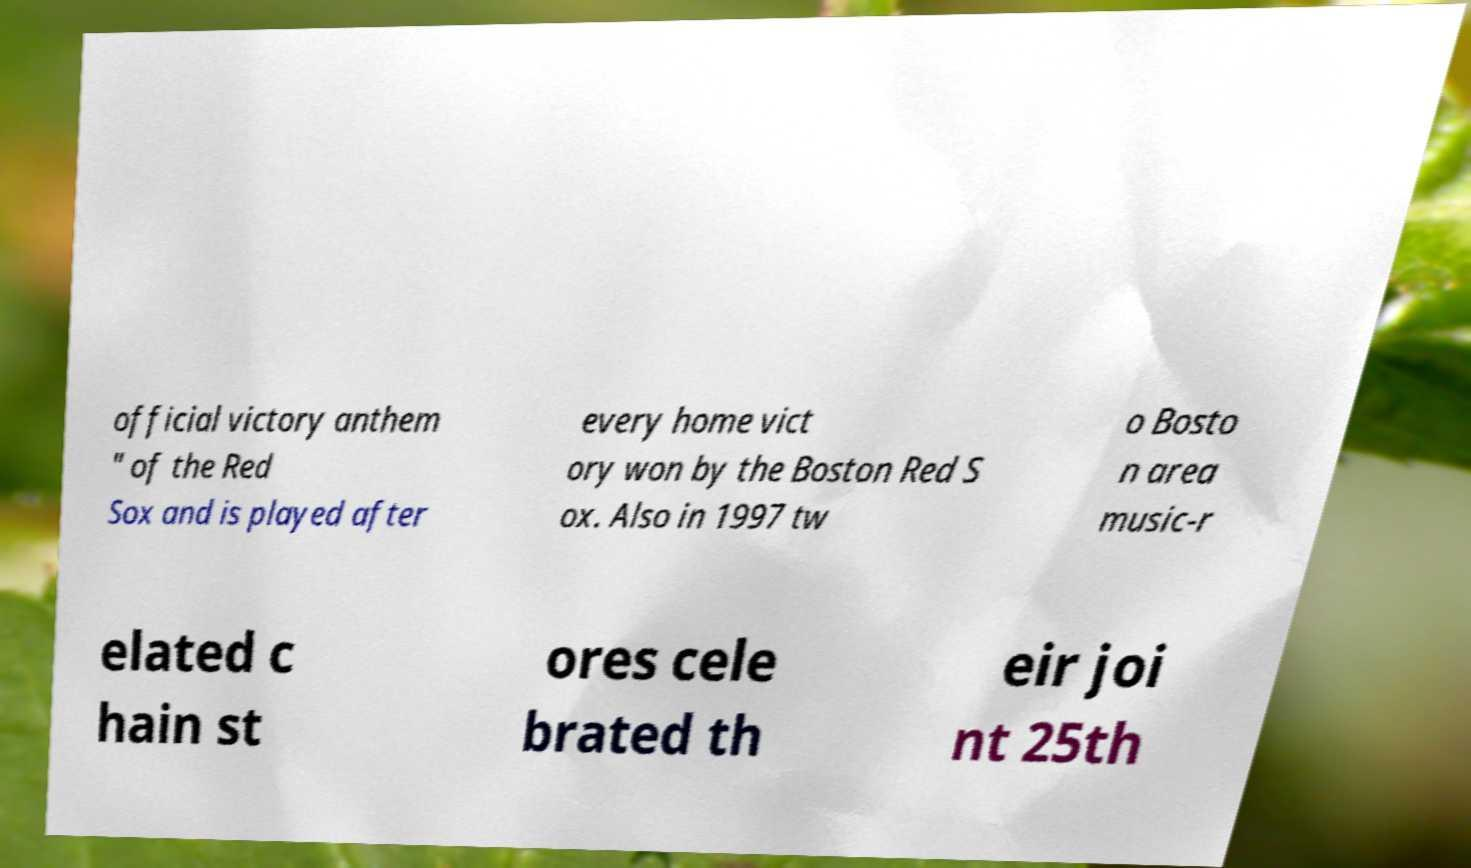What messages or text are displayed in this image? I need them in a readable, typed format. official victory anthem " of the Red Sox and is played after every home vict ory won by the Boston Red S ox. Also in 1997 tw o Bosto n area music-r elated c hain st ores cele brated th eir joi nt 25th 